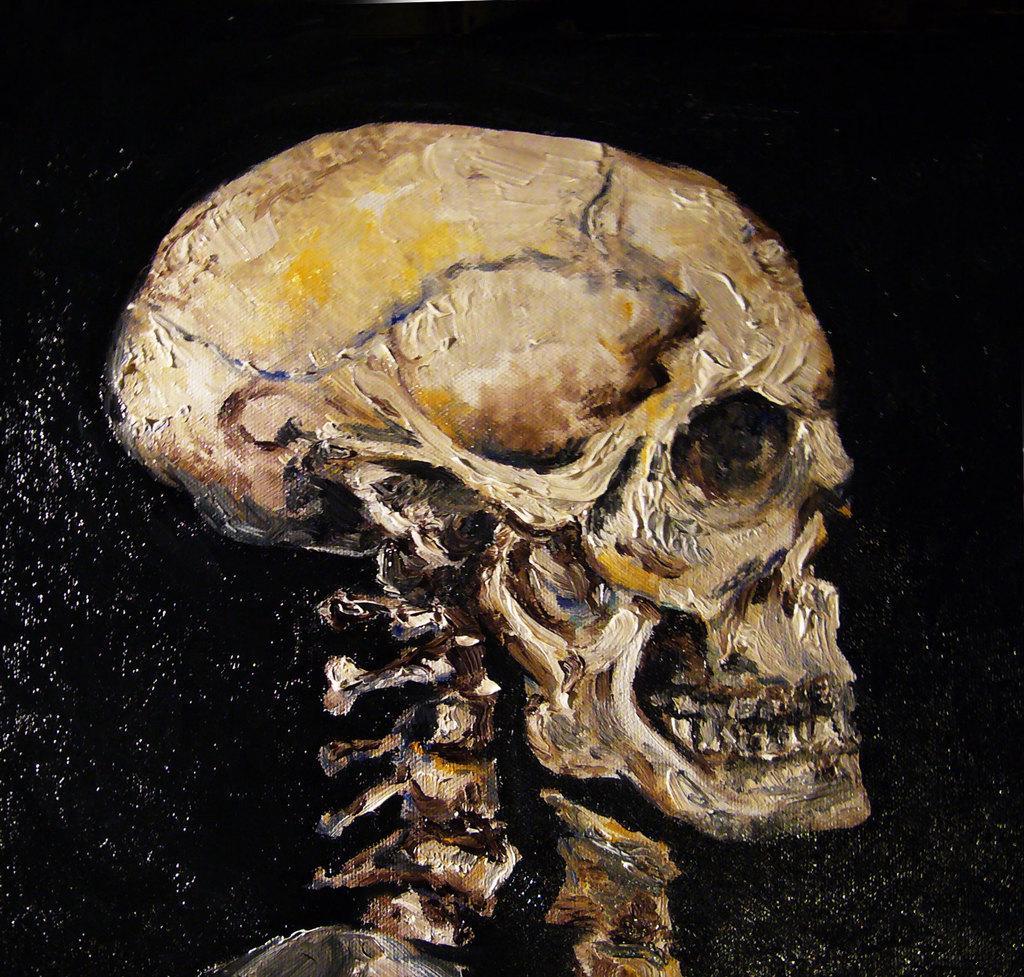In one or two sentences, can you explain what this image depicts? This is the picture of the painting. In this picture, we see the skeleton of the human. In the background, it is black in color. 